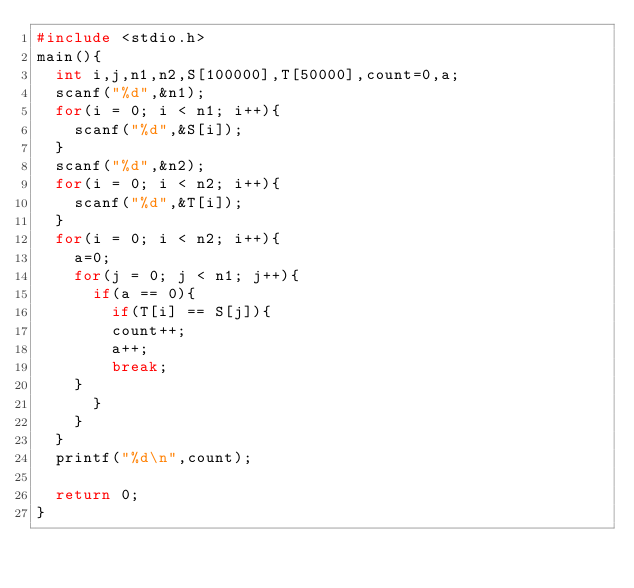<code> <loc_0><loc_0><loc_500><loc_500><_C_>#include <stdio.h>
main(){
  int i,j,n1,n2,S[100000],T[50000],count=0,a;
  scanf("%d",&n1);
  for(i = 0; i < n1; i++){
    scanf("%d",&S[i]);
  }
  scanf("%d",&n2);
  for(i = 0; i < n2; i++){
    scanf("%d",&T[i]);
  }
  for(i = 0; i < n2; i++){
    a=0;
    for(j = 0; j < n1; j++){
      if(a == 0){
        if(T[i] == S[j]){
        count++; 
        a++;
        break;
	}
      }
    }
  }
  printf("%d\n",count);
  
  return 0;
}</code> 